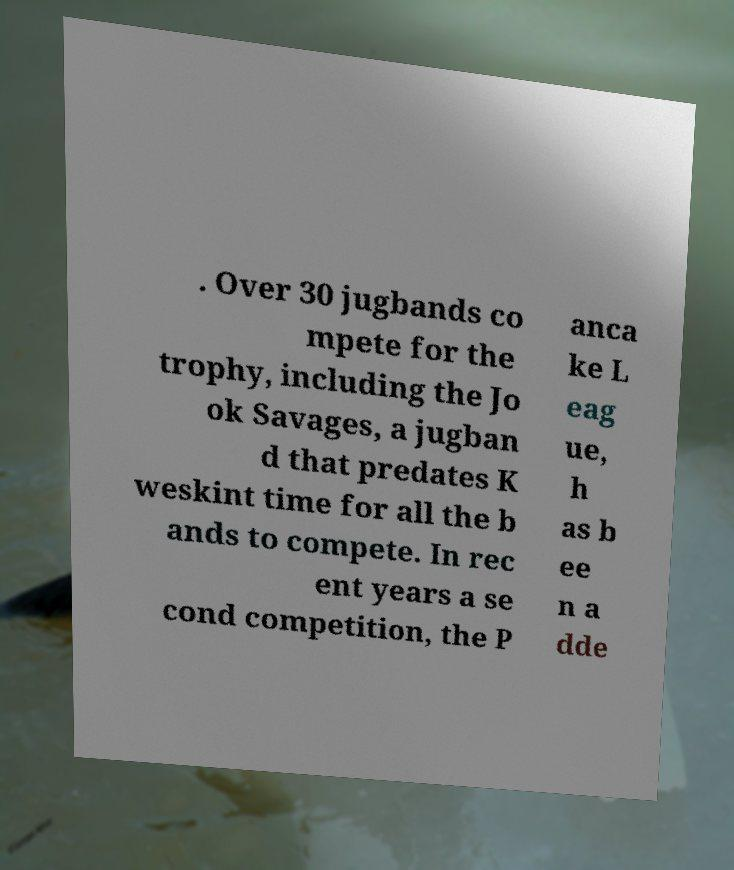I need the written content from this picture converted into text. Can you do that? . Over 30 jugbands co mpete for the trophy, including the Jo ok Savages, a jugban d that predates K weskint time for all the b ands to compete. In rec ent years a se cond competition, the P anca ke L eag ue, h as b ee n a dde 